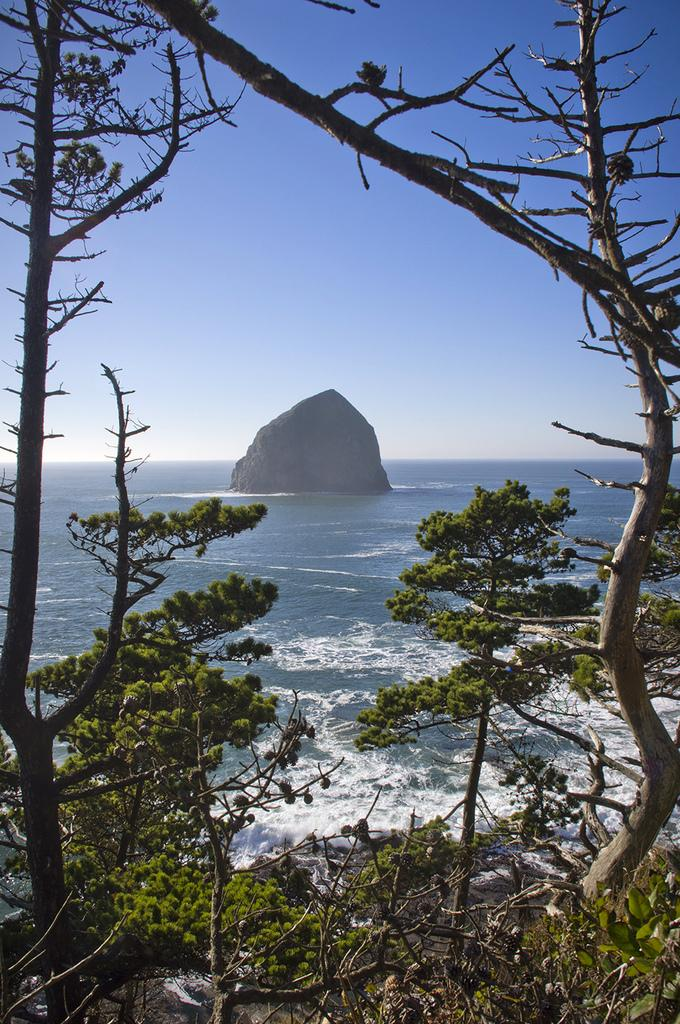What type of vegetation can be seen in the image? There are trees in the image. What natural element is also visible in the image? There is water visible in the image. What geological feature is present in the image? There is a rock in the image. What part of the natural environment is visible in the image? The sky is visible in the image. Can you tell me how many flowers are depicted in the image? There are no flowers present in the image. What type of hen can be seen in the image? There is no hen present in the image. 